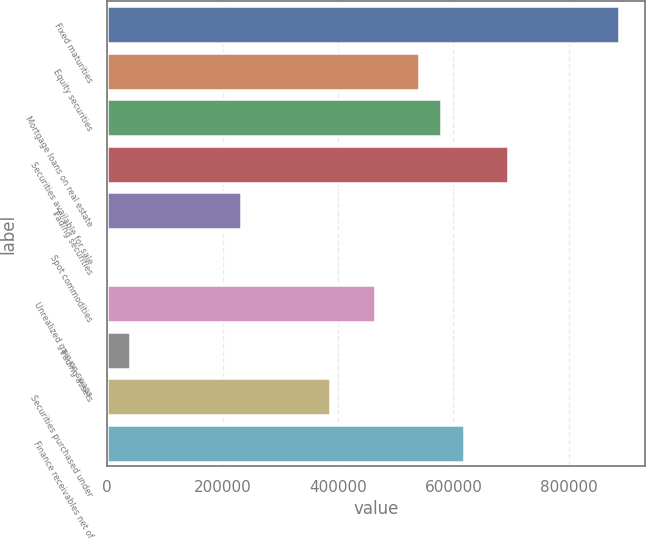Convert chart to OTSL. <chart><loc_0><loc_0><loc_500><loc_500><bar_chart><fcel>Fixed maturities<fcel>Equity securities<fcel>Mortgage loans on real estate<fcel>Securities available for sale<fcel>Trading securities<fcel>Spot commodities<fcel>Unrealized gain on swaps<fcel>Trading assets<fcel>Securities purchased under<fcel>Finance receivables net of<nl><fcel>888133<fcel>540640<fcel>579250<fcel>695081<fcel>231758<fcel>96<fcel>463420<fcel>38706.3<fcel>386199<fcel>617861<nl></chart> 